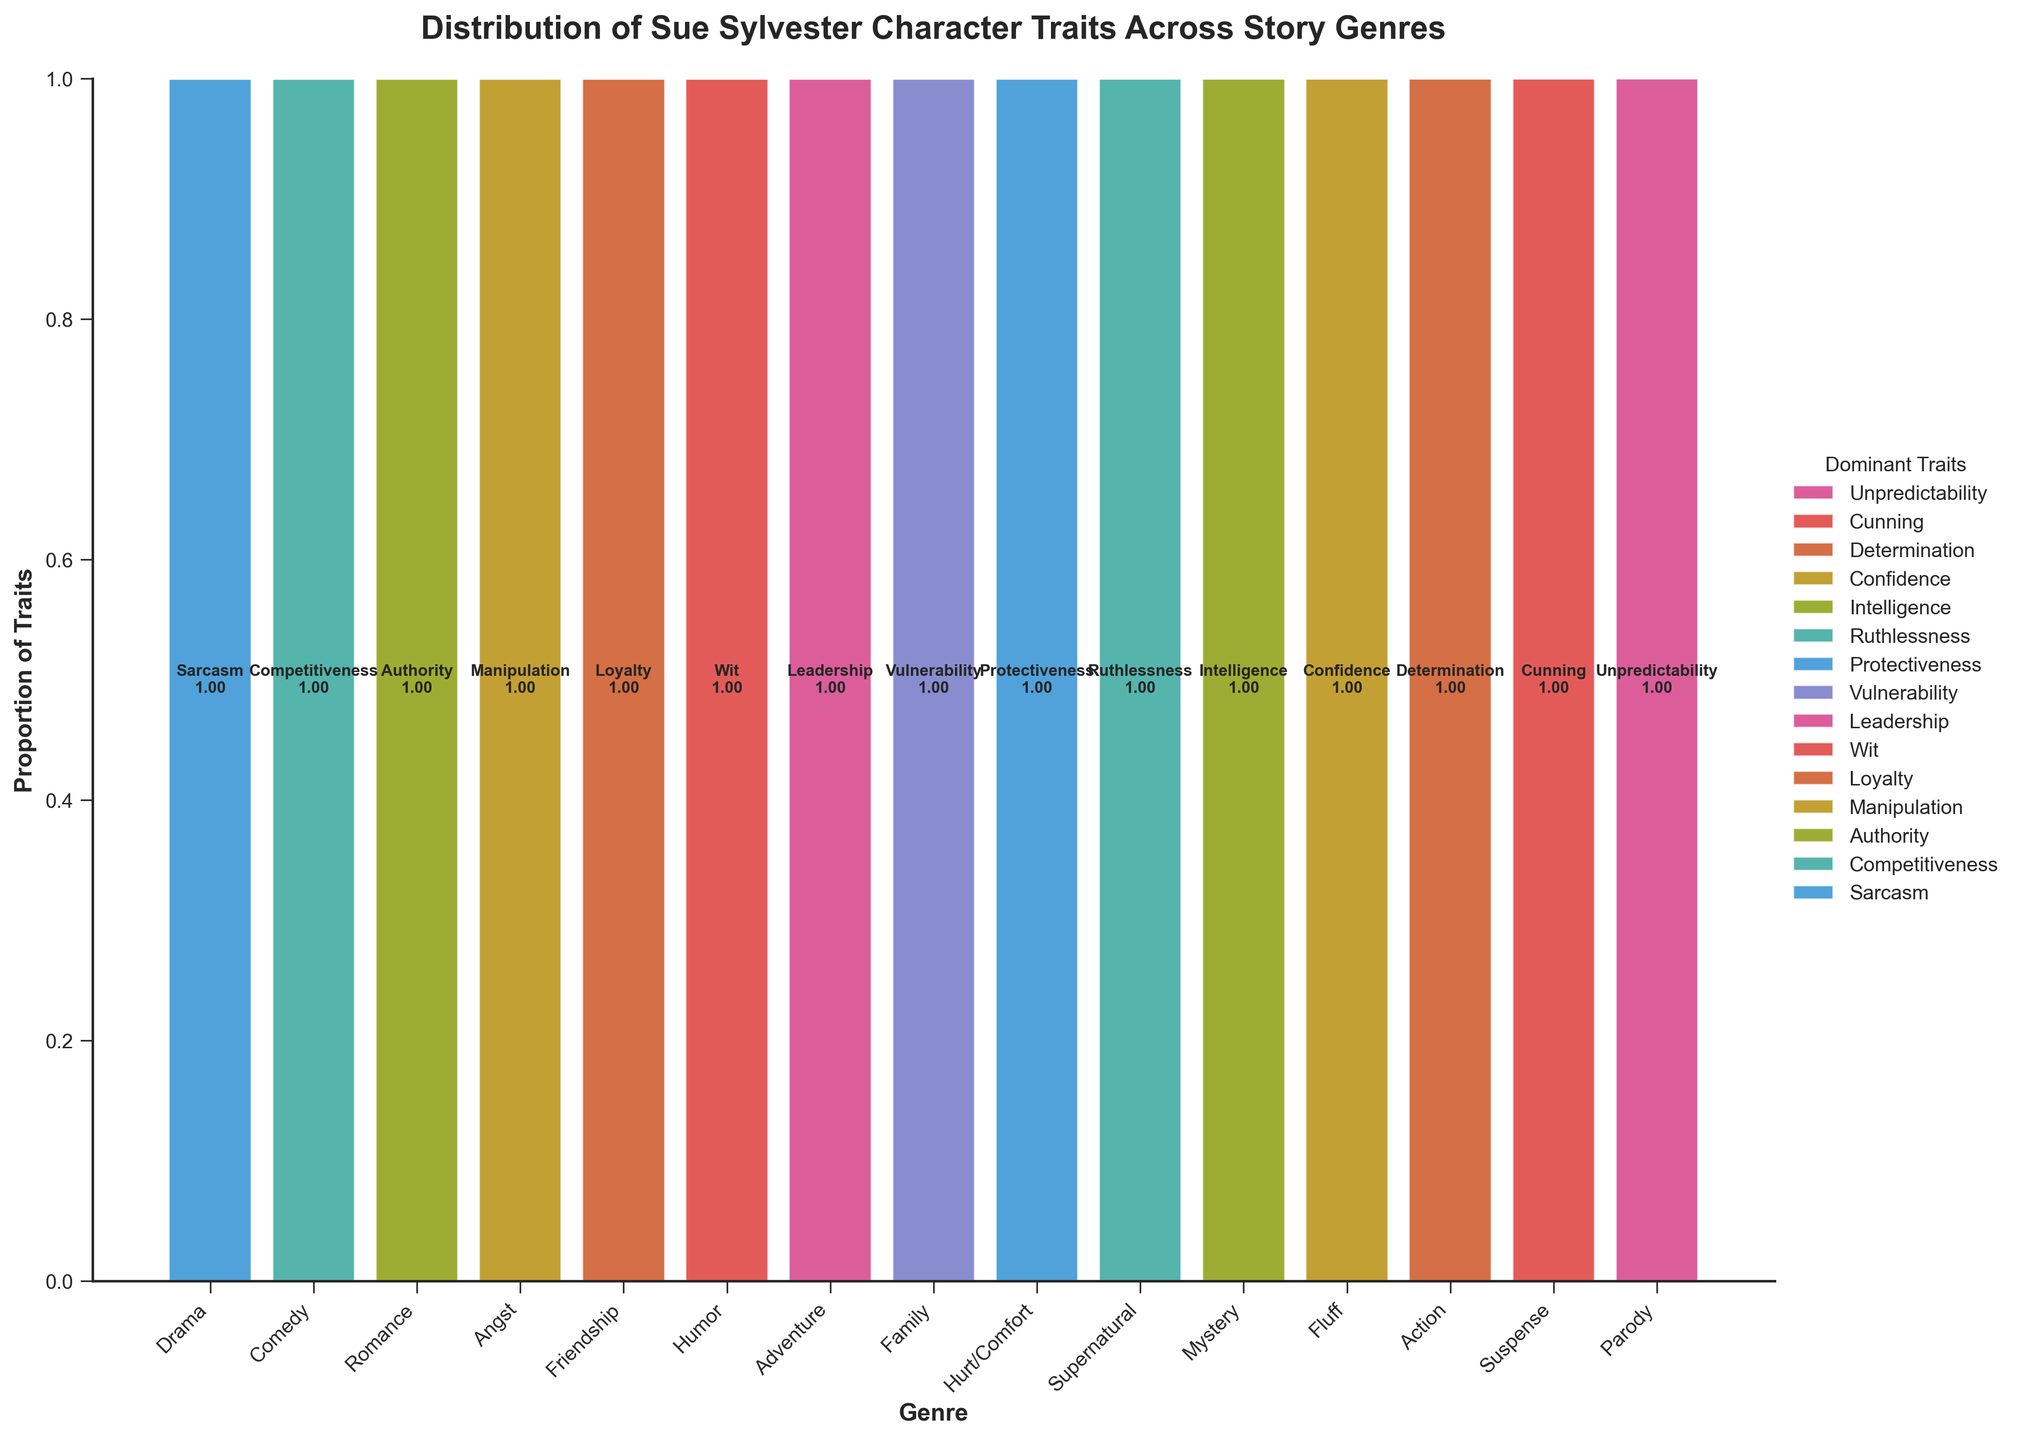What is the title of the plot? The title of the plot is displayed prominently at the top of the figure. It helps to understand what the plot is about.
Answer: Distribution of Sue Sylvester Character Traits Across Story Genres Which genre has the highest proportion of the trait "Leadership"? Observe the segments corresponding to "Leadership" within each genre bar. Identify the bar that shows the largest segment for "Leadership."
Answer: Adventure How many genres include the trait "Sarcasm"? Count the number of genres where a segment labeled "Sarcasm" appears.
Answer: 1 Which dominant trait is most frequently associated with the "Comedy" genre? Look at the "Comedy" bar and identify the dominant trait that occupies the largest proportion.
Answer: Competitiveness Are there any genres where multiple dominant traits have the same proportion? If so, which ones? Check each genre's bar to see if there are segments with equal proportions.
Answer: No Which genre displays the most diverse range of dominant traits? Count the number of different traits represented in each genre's bar. The genre with the highest count has the most diversity.
Answer: Suspense In the genre "Parody," which dominant trait is depicted, and what is its proportion? Check the segment corresponding to the genre "Parody" and note the trait and its size.
Answer: Unpredictability, 1.00 What is the combined proportion of "Loyalty" and "Manipulation" in the genres they appear in? Identify the proportions of "Loyalty" and "Manipulation" in their respective genres and sum them up.
Answer: Loyalty: 1.00, Manipulation: 1.00, Total: 2.00 Which trait appears only once across all genres? Identify any trait that is associated with only one genre by observing all segments.
Answer: Protectiveness Between the genres "Action" and "Romance," which has a higher proportion of its dominant trait? Compare the height of the segments representing the dominant traits of "Action" and "Romance."
Answer: Action 